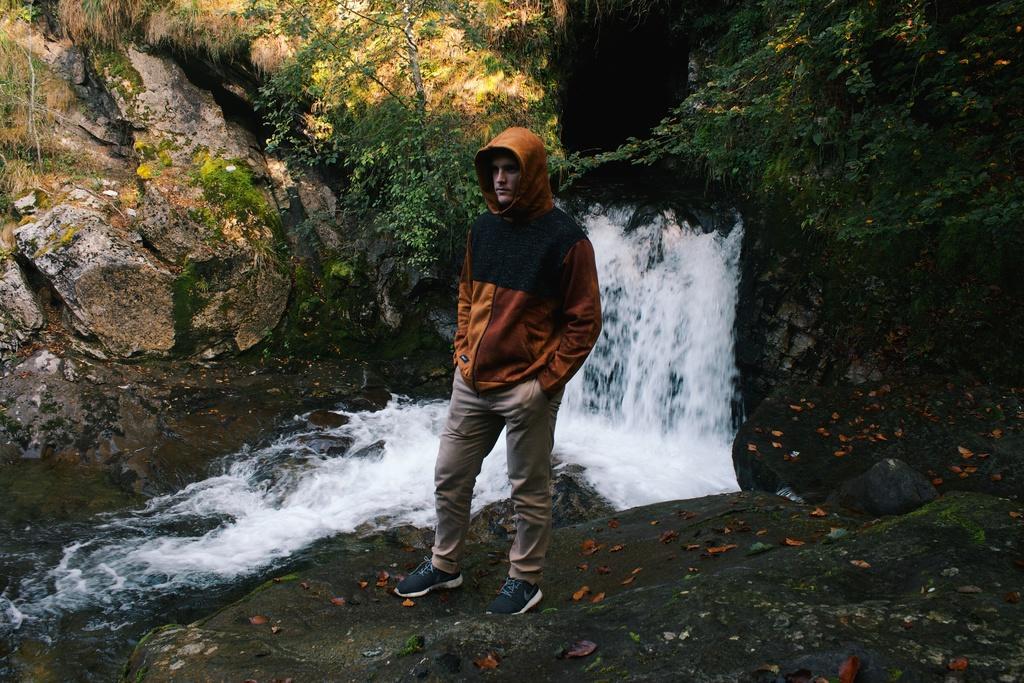In one or two sentences, can you explain what this image depicts? In the image we can see a man standing, wearing clothes and shoes. Here we can see water falls, stones, algae and plants. 